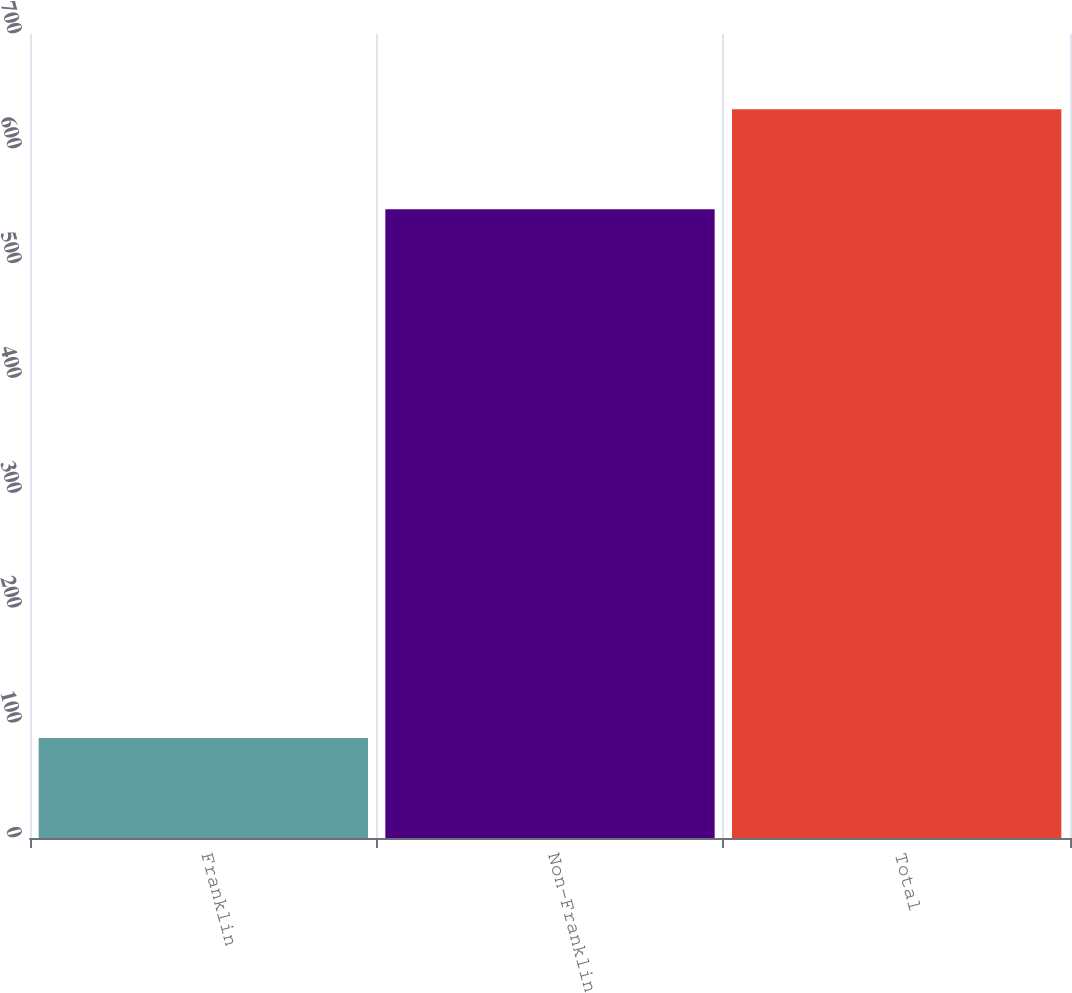Convert chart. <chart><loc_0><loc_0><loc_500><loc_500><bar_chart><fcel>Franklin<fcel>Non-Franklin<fcel>Total<nl><fcel>87<fcel>547.5<fcel>634.5<nl></chart> 